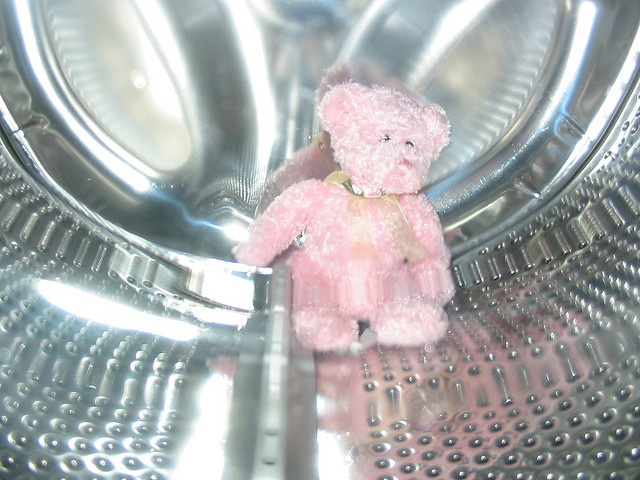Describe the objects in this image and their specific colors. I can see a teddy bear in gray, pink, and darkgray tones in this image. 